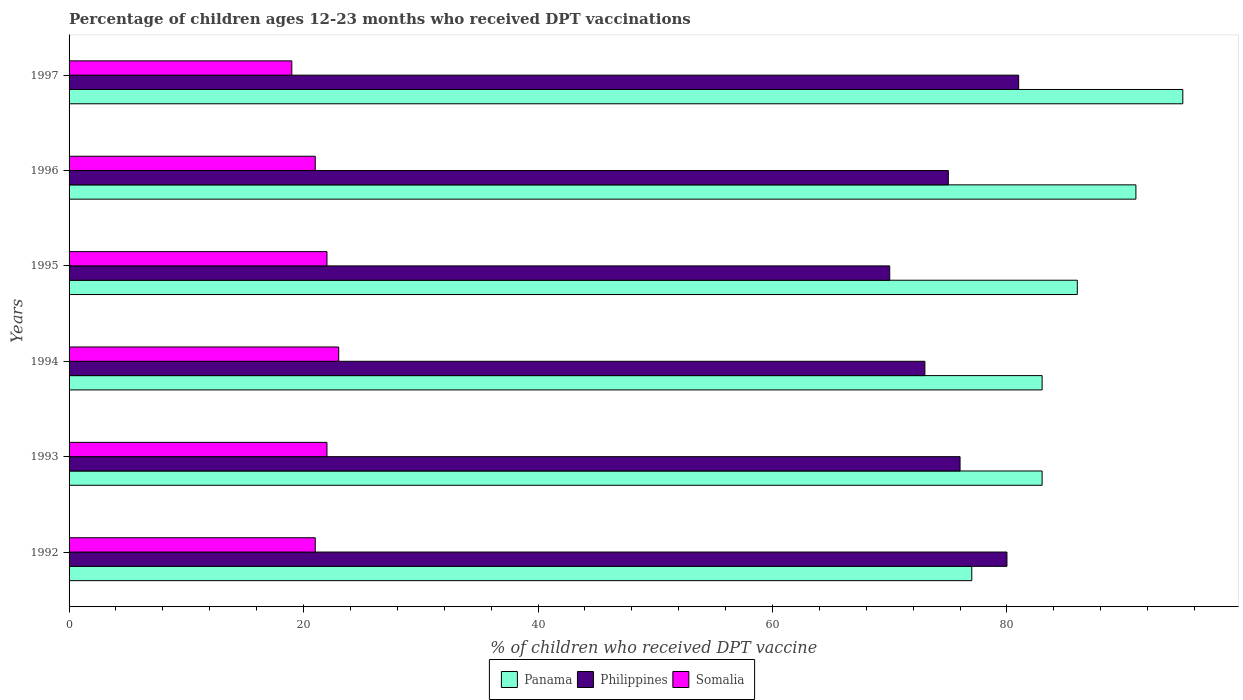How many different coloured bars are there?
Provide a short and direct response. 3. How many groups of bars are there?
Provide a succinct answer. 6. Are the number of bars per tick equal to the number of legend labels?
Provide a short and direct response. Yes. How many bars are there on the 5th tick from the bottom?
Your answer should be very brief. 3. In how many cases, is the number of bars for a given year not equal to the number of legend labels?
Offer a terse response. 0. What is the percentage of children who received DPT vaccination in Panama in 1997?
Keep it short and to the point. 95. Across all years, what is the minimum percentage of children who received DPT vaccination in Philippines?
Your response must be concise. 70. In which year was the percentage of children who received DPT vaccination in Somalia maximum?
Give a very brief answer. 1994. In which year was the percentage of children who received DPT vaccination in Philippines minimum?
Keep it short and to the point. 1995. What is the total percentage of children who received DPT vaccination in Panama in the graph?
Your answer should be very brief. 515. What is the difference between the percentage of children who received DPT vaccination in Panama in 1992 and that in 1995?
Offer a terse response. -9. What is the difference between the percentage of children who received DPT vaccination in Philippines in 1994 and the percentage of children who received DPT vaccination in Panama in 1996?
Provide a short and direct response. -18. What is the average percentage of children who received DPT vaccination in Panama per year?
Ensure brevity in your answer.  85.83. In the year 1993, what is the difference between the percentage of children who received DPT vaccination in Philippines and percentage of children who received DPT vaccination in Somalia?
Make the answer very short. 54. What is the ratio of the percentage of children who received DPT vaccination in Panama in 1994 to that in 1997?
Keep it short and to the point. 0.87. Is the percentage of children who received DPT vaccination in Somalia in 1992 less than that in 1994?
Your answer should be compact. Yes. Is the difference between the percentage of children who received DPT vaccination in Philippines in 1992 and 1996 greater than the difference between the percentage of children who received DPT vaccination in Somalia in 1992 and 1996?
Offer a very short reply. Yes. What is the difference between the highest and the second highest percentage of children who received DPT vaccination in Panama?
Ensure brevity in your answer.  4. What is the difference between the highest and the lowest percentage of children who received DPT vaccination in Panama?
Provide a short and direct response. 18. Is the sum of the percentage of children who received DPT vaccination in Panama in 1993 and 1995 greater than the maximum percentage of children who received DPT vaccination in Somalia across all years?
Your answer should be compact. Yes. What does the 2nd bar from the top in 1994 represents?
Your answer should be very brief. Philippines. What does the 1st bar from the bottom in 1992 represents?
Provide a succinct answer. Panama. Is it the case that in every year, the sum of the percentage of children who received DPT vaccination in Somalia and percentage of children who received DPT vaccination in Philippines is greater than the percentage of children who received DPT vaccination in Panama?
Make the answer very short. Yes. How many bars are there?
Offer a terse response. 18. How many years are there in the graph?
Give a very brief answer. 6. Does the graph contain any zero values?
Make the answer very short. No. What is the title of the graph?
Provide a short and direct response. Percentage of children ages 12-23 months who received DPT vaccinations. What is the label or title of the X-axis?
Provide a short and direct response. % of children who received DPT vaccine. What is the label or title of the Y-axis?
Your response must be concise. Years. What is the % of children who received DPT vaccine of Panama in 1994?
Ensure brevity in your answer.  83. What is the % of children who received DPT vaccine in Philippines in 1994?
Ensure brevity in your answer.  73. What is the % of children who received DPT vaccine of Panama in 1996?
Make the answer very short. 91. What is the % of children who received DPT vaccine of Panama in 1997?
Your answer should be very brief. 95. What is the % of children who received DPT vaccine of Somalia in 1997?
Ensure brevity in your answer.  19. Across all years, what is the maximum % of children who received DPT vaccine of Panama?
Keep it short and to the point. 95. Across all years, what is the maximum % of children who received DPT vaccine in Philippines?
Provide a short and direct response. 81. Across all years, what is the minimum % of children who received DPT vaccine in Philippines?
Keep it short and to the point. 70. Across all years, what is the minimum % of children who received DPT vaccine of Somalia?
Ensure brevity in your answer.  19. What is the total % of children who received DPT vaccine in Panama in the graph?
Ensure brevity in your answer.  515. What is the total % of children who received DPT vaccine in Philippines in the graph?
Your answer should be compact. 455. What is the total % of children who received DPT vaccine in Somalia in the graph?
Make the answer very short. 128. What is the difference between the % of children who received DPT vaccine of Philippines in 1992 and that in 1994?
Your response must be concise. 7. What is the difference between the % of children who received DPT vaccine of Somalia in 1992 and that in 1994?
Your answer should be compact. -2. What is the difference between the % of children who received DPT vaccine in Panama in 1992 and that in 1996?
Ensure brevity in your answer.  -14. What is the difference between the % of children who received DPT vaccine of Panama in 1992 and that in 1997?
Your response must be concise. -18. What is the difference between the % of children who received DPT vaccine in Philippines in 1992 and that in 1997?
Give a very brief answer. -1. What is the difference between the % of children who received DPT vaccine in Somalia in 1992 and that in 1997?
Keep it short and to the point. 2. What is the difference between the % of children who received DPT vaccine in Panama in 1993 and that in 1994?
Your response must be concise. 0. What is the difference between the % of children who received DPT vaccine of Philippines in 1993 and that in 1994?
Offer a terse response. 3. What is the difference between the % of children who received DPT vaccine in Philippines in 1993 and that in 1995?
Keep it short and to the point. 6. What is the difference between the % of children who received DPT vaccine in Panama in 1993 and that in 1996?
Provide a succinct answer. -8. What is the difference between the % of children who received DPT vaccine of Philippines in 1993 and that in 1997?
Provide a succinct answer. -5. What is the difference between the % of children who received DPT vaccine in Somalia in 1993 and that in 1997?
Offer a very short reply. 3. What is the difference between the % of children who received DPT vaccine of Somalia in 1994 and that in 1995?
Keep it short and to the point. 1. What is the difference between the % of children who received DPT vaccine in Panama in 1994 and that in 1996?
Your answer should be compact. -8. What is the difference between the % of children who received DPT vaccine of Philippines in 1994 and that in 1996?
Make the answer very short. -2. What is the difference between the % of children who received DPT vaccine of Philippines in 1994 and that in 1997?
Your answer should be compact. -8. What is the difference between the % of children who received DPT vaccine in Philippines in 1995 and that in 1997?
Your answer should be compact. -11. What is the difference between the % of children who received DPT vaccine in Somalia in 1995 and that in 1997?
Your answer should be compact. 3. What is the difference between the % of children who received DPT vaccine of Panama in 1996 and that in 1997?
Keep it short and to the point. -4. What is the difference between the % of children who received DPT vaccine of Panama in 1992 and the % of children who received DPT vaccine of Philippines in 1993?
Provide a short and direct response. 1. What is the difference between the % of children who received DPT vaccine in Panama in 1992 and the % of children who received DPT vaccine in Philippines in 1994?
Keep it short and to the point. 4. What is the difference between the % of children who received DPT vaccine of Panama in 1992 and the % of children who received DPT vaccine of Philippines in 1995?
Keep it short and to the point. 7. What is the difference between the % of children who received DPT vaccine in Panama in 1992 and the % of children who received DPT vaccine in Philippines in 1996?
Provide a succinct answer. 2. What is the difference between the % of children who received DPT vaccine of Panama in 1992 and the % of children who received DPT vaccine of Philippines in 1997?
Your answer should be very brief. -4. What is the difference between the % of children who received DPT vaccine of Panama in 1993 and the % of children who received DPT vaccine of Philippines in 1994?
Provide a short and direct response. 10. What is the difference between the % of children who received DPT vaccine in Panama in 1993 and the % of children who received DPT vaccine in Somalia in 1994?
Your answer should be compact. 60. What is the difference between the % of children who received DPT vaccine of Philippines in 1993 and the % of children who received DPT vaccine of Somalia in 1994?
Your answer should be very brief. 53. What is the difference between the % of children who received DPT vaccine of Panama in 1993 and the % of children who received DPT vaccine of Philippines in 1995?
Ensure brevity in your answer.  13. What is the difference between the % of children who received DPT vaccine in Panama in 1993 and the % of children who received DPT vaccine in Philippines in 1997?
Provide a succinct answer. 2. What is the difference between the % of children who received DPT vaccine of Panama in 1993 and the % of children who received DPT vaccine of Somalia in 1997?
Offer a terse response. 64. What is the difference between the % of children who received DPT vaccine in Panama in 1994 and the % of children who received DPT vaccine in Philippines in 1996?
Give a very brief answer. 8. What is the difference between the % of children who received DPT vaccine of Panama in 1994 and the % of children who received DPT vaccine of Somalia in 1996?
Offer a very short reply. 62. What is the difference between the % of children who received DPT vaccine of Panama in 1994 and the % of children who received DPT vaccine of Somalia in 1997?
Your response must be concise. 64. What is the difference between the % of children who received DPT vaccine in Panama in 1995 and the % of children who received DPT vaccine in Philippines in 1996?
Offer a terse response. 11. What is the difference between the % of children who received DPT vaccine in Panama in 1995 and the % of children who received DPT vaccine in Somalia in 1996?
Provide a succinct answer. 65. What is the difference between the % of children who received DPT vaccine of Philippines in 1995 and the % of children who received DPT vaccine of Somalia in 1997?
Ensure brevity in your answer.  51. What is the difference between the % of children who received DPT vaccine of Panama in 1996 and the % of children who received DPT vaccine of Somalia in 1997?
Your answer should be very brief. 72. What is the average % of children who received DPT vaccine in Panama per year?
Provide a short and direct response. 85.83. What is the average % of children who received DPT vaccine in Philippines per year?
Your answer should be very brief. 75.83. What is the average % of children who received DPT vaccine of Somalia per year?
Provide a short and direct response. 21.33. In the year 1992, what is the difference between the % of children who received DPT vaccine in Philippines and % of children who received DPT vaccine in Somalia?
Make the answer very short. 59. In the year 1993, what is the difference between the % of children who received DPT vaccine of Panama and % of children who received DPT vaccine of Philippines?
Give a very brief answer. 7. In the year 1993, what is the difference between the % of children who received DPT vaccine in Panama and % of children who received DPT vaccine in Somalia?
Your answer should be very brief. 61. In the year 1994, what is the difference between the % of children who received DPT vaccine in Panama and % of children who received DPT vaccine in Philippines?
Ensure brevity in your answer.  10. In the year 1994, what is the difference between the % of children who received DPT vaccine of Philippines and % of children who received DPT vaccine of Somalia?
Give a very brief answer. 50. In the year 1995, what is the difference between the % of children who received DPT vaccine of Panama and % of children who received DPT vaccine of Somalia?
Your answer should be compact. 64. In the year 1996, what is the difference between the % of children who received DPT vaccine in Panama and % of children who received DPT vaccine in Philippines?
Ensure brevity in your answer.  16. In the year 1996, what is the difference between the % of children who received DPT vaccine of Panama and % of children who received DPT vaccine of Somalia?
Keep it short and to the point. 70. In the year 1996, what is the difference between the % of children who received DPT vaccine of Philippines and % of children who received DPT vaccine of Somalia?
Offer a very short reply. 54. In the year 1997, what is the difference between the % of children who received DPT vaccine of Panama and % of children who received DPT vaccine of Somalia?
Ensure brevity in your answer.  76. What is the ratio of the % of children who received DPT vaccine of Panama in 1992 to that in 1993?
Your answer should be compact. 0.93. What is the ratio of the % of children who received DPT vaccine of Philippines in 1992 to that in 1993?
Ensure brevity in your answer.  1.05. What is the ratio of the % of children who received DPT vaccine of Somalia in 1992 to that in 1993?
Make the answer very short. 0.95. What is the ratio of the % of children who received DPT vaccine in Panama in 1992 to that in 1994?
Provide a succinct answer. 0.93. What is the ratio of the % of children who received DPT vaccine in Philippines in 1992 to that in 1994?
Your answer should be compact. 1.1. What is the ratio of the % of children who received DPT vaccine in Panama in 1992 to that in 1995?
Make the answer very short. 0.9. What is the ratio of the % of children who received DPT vaccine in Philippines in 1992 to that in 1995?
Your answer should be very brief. 1.14. What is the ratio of the % of children who received DPT vaccine of Somalia in 1992 to that in 1995?
Make the answer very short. 0.95. What is the ratio of the % of children who received DPT vaccine of Panama in 1992 to that in 1996?
Keep it short and to the point. 0.85. What is the ratio of the % of children who received DPT vaccine in Philippines in 1992 to that in 1996?
Make the answer very short. 1.07. What is the ratio of the % of children who received DPT vaccine of Panama in 1992 to that in 1997?
Offer a terse response. 0.81. What is the ratio of the % of children who received DPT vaccine of Philippines in 1992 to that in 1997?
Your answer should be compact. 0.99. What is the ratio of the % of children who received DPT vaccine in Somalia in 1992 to that in 1997?
Keep it short and to the point. 1.11. What is the ratio of the % of children who received DPT vaccine in Panama in 1993 to that in 1994?
Offer a very short reply. 1. What is the ratio of the % of children who received DPT vaccine in Philippines in 1993 to that in 1994?
Offer a very short reply. 1.04. What is the ratio of the % of children who received DPT vaccine of Somalia in 1993 to that in 1994?
Offer a very short reply. 0.96. What is the ratio of the % of children who received DPT vaccine of Panama in 1993 to that in 1995?
Provide a short and direct response. 0.97. What is the ratio of the % of children who received DPT vaccine in Philippines in 1993 to that in 1995?
Give a very brief answer. 1.09. What is the ratio of the % of children who received DPT vaccine in Somalia in 1993 to that in 1995?
Make the answer very short. 1. What is the ratio of the % of children who received DPT vaccine of Panama in 1993 to that in 1996?
Keep it short and to the point. 0.91. What is the ratio of the % of children who received DPT vaccine in Philippines in 1993 to that in 1996?
Provide a short and direct response. 1.01. What is the ratio of the % of children who received DPT vaccine of Somalia in 1993 to that in 1996?
Offer a terse response. 1.05. What is the ratio of the % of children who received DPT vaccine of Panama in 1993 to that in 1997?
Make the answer very short. 0.87. What is the ratio of the % of children who received DPT vaccine in Philippines in 1993 to that in 1997?
Keep it short and to the point. 0.94. What is the ratio of the % of children who received DPT vaccine in Somalia in 1993 to that in 1997?
Provide a short and direct response. 1.16. What is the ratio of the % of children who received DPT vaccine in Panama in 1994 to that in 1995?
Ensure brevity in your answer.  0.97. What is the ratio of the % of children who received DPT vaccine in Philippines in 1994 to that in 1995?
Keep it short and to the point. 1.04. What is the ratio of the % of children who received DPT vaccine of Somalia in 1994 to that in 1995?
Provide a succinct answer. 1.05. What is the ratio of the % of children who received DPT vaccine of Panama in 1994 to that in 1996?
Your answer should be very brief. 0.91. What is the ratio of the % of children who received DPT vaccine in Philippines in 1994 to that in 1996?
Give a very brief answer. 0.97. What is the ratio of the % of children who received DPT vaccine in Somalia in 1994 to that in 1996?
Give a very brief answer. 1.1. What is the ratio of the % of children who received DPT vaccine in Panama in 1994 to that in 1997?
Provide a succinct answer. 0.87. What is the ratio of the % of children who received DPT vaccine in Philippines in 1994 to that in 1997?
Your answer should be compact. 0.9. What is the ratio of the % of children who received DPT vaccine of Somalia in 1994 to that in 1997?
Make the answer very short. 1.21. What is the ratio of the % of children who received DPT vaccine of Panama in 1995 to that in 1996?
Provide a short and direct response. 0.95. What is the ratio of the % of children who received DPT vaccine of Somalia in 1995 to that in 1996?
Ensure brevity in your answer.  1.05. What is the ratio of the % of children who received DPT vaccine in Panama in 1995 to that in 1997?
Your response must be concise. 0.91. What is the ratio of the % of children who received DPT vaccine in Philippines in 1995 to that in 1997?
Give a very brief answer. 0.86. What is the ratio of the % of children who received DPT vaccine in Somalia in 1995 to that in 1997?
Provide a succinct answer. 1.16. What is the ratio of the % of children who received DPT vaccine of Panama in 1996 to that in 1997?
Ensure brevity in your answer.  0.96. What is the ratio of the % of children who received DPT vaccine in Philippines in 1996 to that in 1997?
Offer a very short reply. 0.93. What is the ratio of the % of children who received DPT vaccine of Somalia in 1996 to that in 1997?
Give a very brief answer. 1.11. What is the difference between the highest and the second highest % of children who received DPT vaccine in Panama?
Your response must be concise. 4. What is the difference between the highest and the second highest % of children who received DPT vaccine in Somalia?
Give a very brief answer. 1. What is the difference between the highest and the lowest % of children who received DPT vaccine in Panama?
Your response must be concise. 18. What is the difference between the highest and the lowest % of children who received DPT vaccine of Somalia?
Ensure brevity in your answer.  4. 